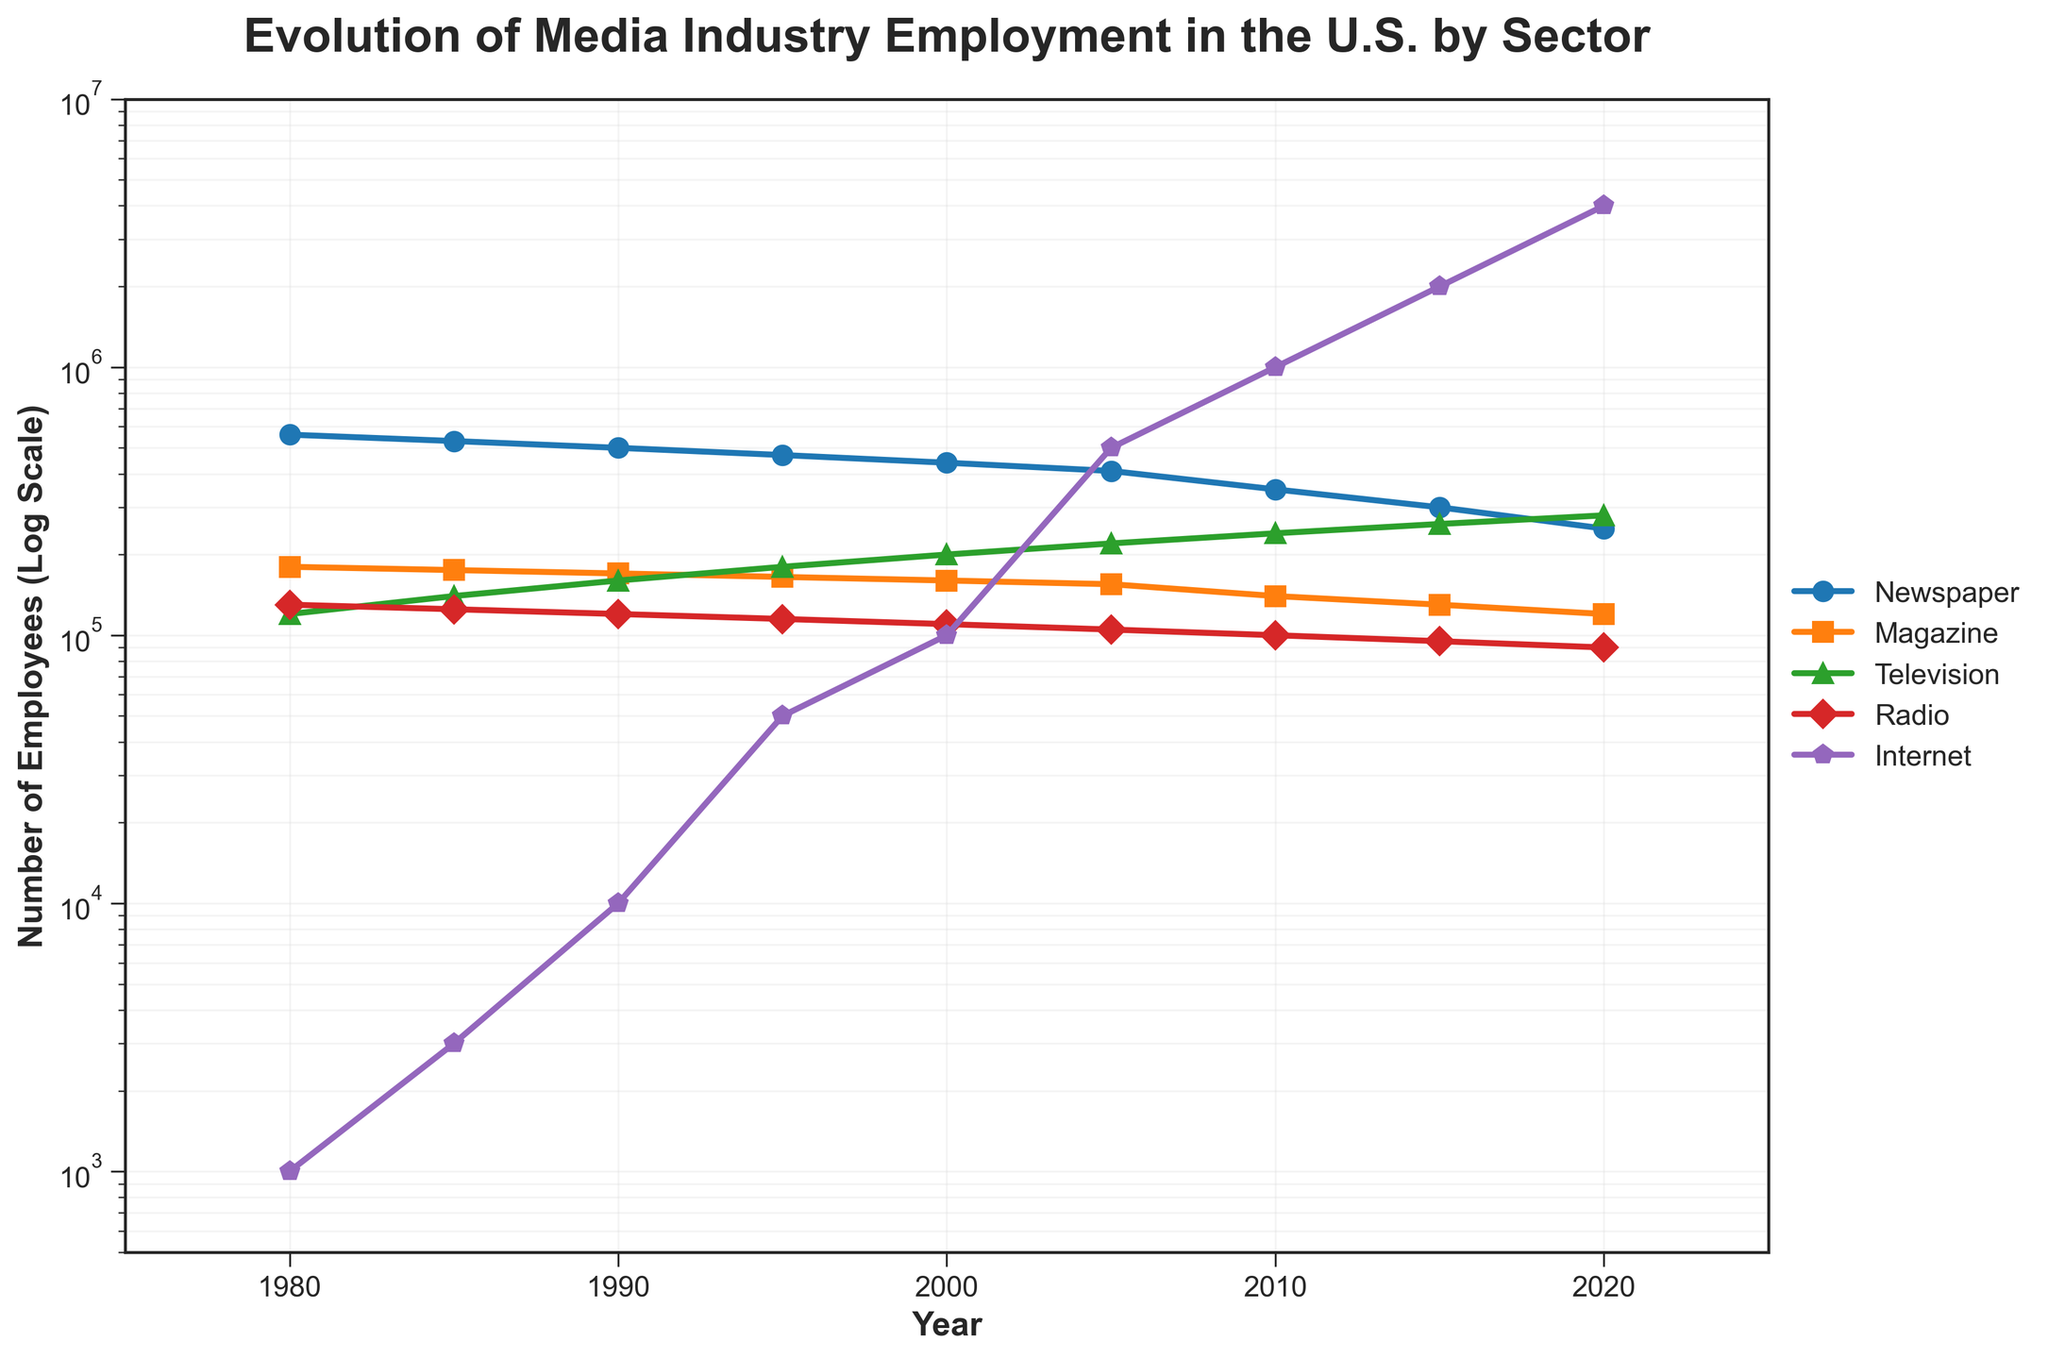What is the overall trend in newspaper employment from 1980 to 2020? The line for Newspaper employment shows a clear downward trend from 560,000 in 1980 to 250,000 in 2020.
Answer: Downward Which sector saw the most substantial growth in employment from 1980 to 2020? Comparing the initial and final data points, the Internet sector shows the most substantial growth, from just 1,000 in 1980 to 4,000,000 in 2020.
Answer: Internet What is the title of the plot? The title is displayed at the top of the plot, indicating the main subject of the chart.
Answer: Evolution of Media Industry Employment in the U.S. by Sector How does employment in the television sector in 2020 compare to employment in the magazine sector in 1980? The television sector in 2020 has approximately 280,000 employees while the magazine sector in 1980 has about 180,000 employees. So, the television sector in 2020 has higher employment.
Answer: Higher in television sector In which year did internet employment exceed the combined employment of newspapers and magazines? By inspecting the graph, we see Internet employment first surpassed the combined sum of newspaper and magazine employment around 2010.
Answer: 2010 What is the approximate range of values on the Y-axis? The Y-axis employs a logarithmic scale and ranges from approximately 500 to 10,000,000 employees.
Answer: 500 to 10,000,000 Compare the trends in radio employment and television employment. The radio employment shows a slow decline from 130,000 in 1980 to 90,000 in 2020, whereas television employment shows a steady increase from 120,000 in 1980 to 280,000 in 2020.
Answer: Radio declining, Television increasing What is the employment difference between television and radio sectors in 2020? In 2020, television employment is 280,000 and radio employment is 90,000. Subtracting these, the difference is 280,000 - 90,000 = 190,000.
Answer: 190,000 Which two sectors had the closest employment figures in 1985? In 1985, the television sector had 140,000 employees and the magazine sector had 175,000 employees. These two sectors had the closest employment figures in that year.
Answer: Television and Magazine At what point did the employment in the magazine sector start to decline? Employment in the magazine sector starts to show a clear decline after 2000, where it reduces from 160,000 to 155,000.
Answer: After 2000 